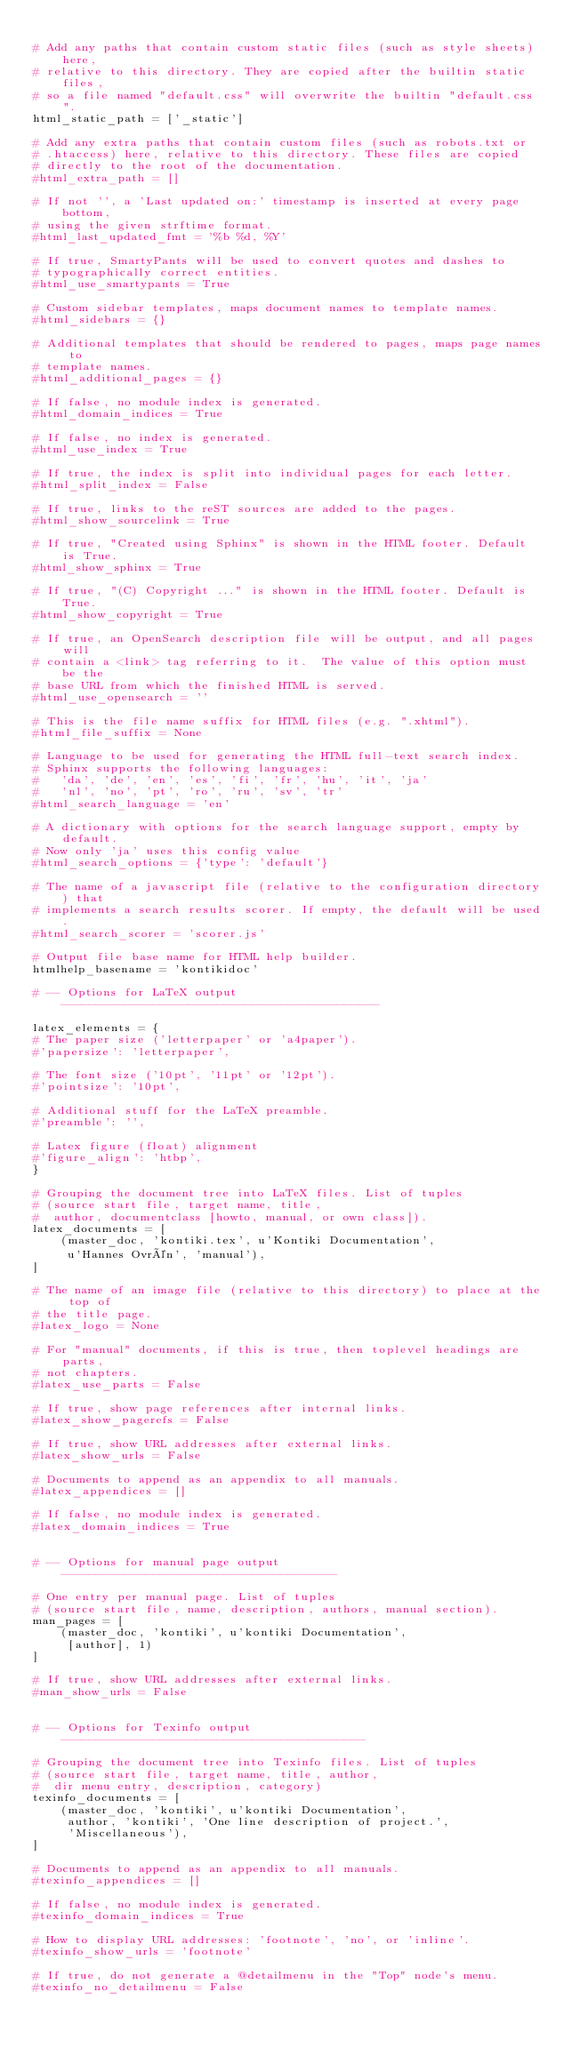<code> <loc_0><loc_0><loc_500><loc_500><_Python_>
# Add any paths that contain custom static files (such as style sheets) here,
# relative to this directory. They are copied after the builtin static files,
# so a file named "default.css" will overwrite the builtin "default.css".
html_static_path = ['_static']

# Add any extra paths that contain custom files (such as robots.txt or
# .htaccess) here, relative to this directory. These files are copied
# directly to the root of the documentation.
#html_extra_path = []

# If not '', a 'Last updated on:' timestamp is inserted at every page bottom,
# using the given strftime format.
#html_last_updated_fmt = '%b %d, %Y'

# If true, SmartyPants will be used to convert quotes and dashes to
# typographically correct entities.
#html_use_smartypants = True

# Custom sidebar templates, maps document names to template names.
#html_sidebars = {}

# Additional templates that should be rendered to pages, maps page names to
# template names.
#html_additional_pages = {}

# If false, no module index is generated.
#html_domain_indices = True

# If false, no index is generated.
#html_use_index = True

# If true, the index is split into individual pages for each letter.
#html_split_index = False

# If true, links to the reST sources are added to the pages.
#html_show_sourcelink = True

# If true, "Created using Sphinx" is shown in the HTML footer. Default is True.
#html_show_sphinx = True

# If true, "(C) Copyright ..." is shown in the HTML footer. Default is True.
#html_show_copyright = True

# If true, an OpenSearch description file will be output, and all pages will
# contain a <link> tag referring to it.  The value of this option must be the
# base URL from which the finished HTML is served.
#html_use_opensearch = ''

# This is the file name suffix for HTML files (e.g. ".xhtml").
#html_file_suffix = None

# Language to be used for generating the HTML full-text search index.
# Sphinx supports the following languages:
#   'da', 'de', 'en', 'es', 'fi', 'fr', 'hu', 'it', 'ja'
#   'nl', 'no', 'pt', 'ro', 'ru', 'sv', 'tr'
#html_search_language = 'en'

# A dictionary with options for the search language support, empty by default.
# Now only 'ja' uses this config value
#html_search_options = {'type': 'default'}

# The name of a javascript file (relative to the configuration directory) that
# implements a search results scorer. If empty, the default will be used.
#html_search_scorer = 'scorer.js'

# Output file base name for HTML help builder.
htmlhelp_basename = 'kontikidoc'

# -- Options for LaTeX output ---------------------------------------------

latex_elements = {
# The paper size ('letterpaper' or 'a4paper').
#'papersize': 'letterpaper',

# The font size ('10pt', '11pt' or '12pt').
#'pointsize': '10pt',

# Additional stuff for the LaTeX preamble.
#'preamble': '',

# Latex figure (float) alignment
#'figure_align': 'htbp',
}

# Grouping the document tree into LaTeX files. List of tuples
# (source start file, target name, title,
#  author, documentclass [howto, manual, or own class]).
latex_documents = [
    (master_doc, 'kontiki.tex', u'Kontiki Documentation',
     u'Hannes Ovrén', 'manual'),
]

# The name of an image file (relative to this directory) to place at the top of
# the title page.
#latex_logo = None

# For "manual" documents, if this is true, then toplevel headings are parts,
# not chapters.
#latex_use_parts = False

# If true, show page references after internal links.
#latex_show_pagerefs = False

# If true, show URL addresses after external links.
#latex_show_urls = False

# Documents to append as an appendix to all manuals.
#latex_appendices = []

# If false, no module index is generated.
#latex_domain_indices = True


# -- Options for manual page output ---------------------------------------

# One entry per manual page. List of tuples
# (source start file, name, description, authors, manual section).
man_pages = [
    (master_doc, 'kontiki', u'kontiki Documentation',
     [author], 1)
]

# If true, show URL addresses after external links.
#man_show_urls = False


# -- Options for Texinfo output -------------------------------------------

# Grouping the document tree into Texinfo files. List of tuples
# (source start file, target name, title, author,
#  dir menu entry, description, category)
texinfo_documents = [
    (master_doc, 'kontiki', u'kontiki Documentation',
     author, 'kontiki', 'One line description of project.',
     'Miscellaneous'),
]

# Documents to append as an appendix to all manuals.
#texinfo_appendices = []

# If false, no module index is generated.
#texinfo_domain_indices = True

# How to display URL addresses: 'footnote', 'no', or 'inline'.
#texinfo_show_urls = 'footnote'

# If true, do not generate a @detailmenu in the "Top" node's menu.
#texinfo_no_detailmenu = False
</code> 